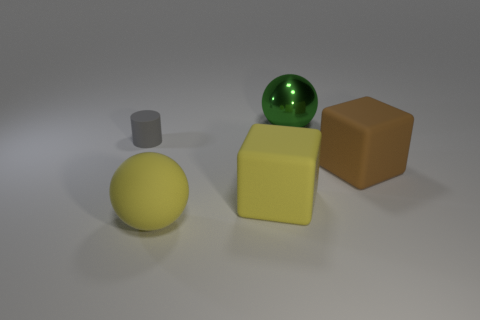Are there any other things that are the same material as the large green thing?
Ensure brevity in your answer.  No. What is the size of the sphere in front of the large green shiny object?
Give a very brief answer. Large. There is a big object behind the tiny gray rubber object; is there a large green thing in front of it?
Provide a succinct answer. No. How many other things are the same shape as the tiny object?
Make the answer very short. 0. What color is the thing that is both behind the brown object and right of the gray rubber cylinder?
Provide a succinct answer. Green. There is a rubber block that is the same color as the rubber ball; what is its size?
Offer a very short reply. Large. How many big things are rubber blocks or brown cubes?
Your answer should be very brief. 2. Is there anything else that has the same color as the metal ball?
Offer a terse response. No. What material is the ball that is behind the large ball that is left of the object that is behind the gray object?
Give a very brief answer. Metal. What number of matte things are either balls or yellow spheres?
Keep it short and to the point. 1. 